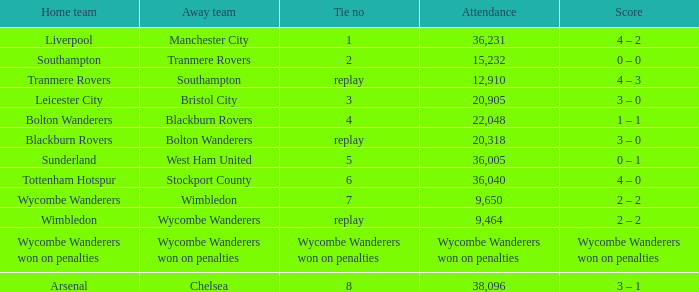What was the score for the game where the home team was Wycombe Wanderers? 2 – 2. 